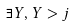<formula> <loc_0><loc_0><loc_500><loc_500>\exists Y , Y > j</formula> 